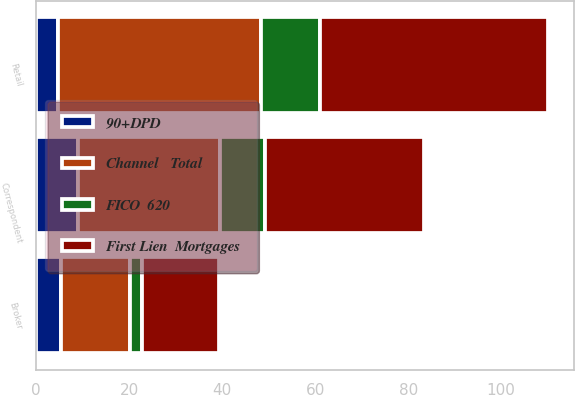Convert chart. <chart><loc_0><loc_0><loc_500><loc_500><stacked_bar_chart><ecel><fcel>Retail<fcel>Broker<fcel>Correspondent<nl><fcel>Channel   Total<fcel>43.6<fcel>14.8<fcel>30.6<nl><fcel>First Lien  Mortgages<fcel>49<fcel>16.7<fcel>34.3<nl><fcel>90+DPD<fcel>4.8<fcel>5.4<fcel>9<nl><fcel>FICO  620<fcel>12.7<fcel>2.5<fcel>9.6<nl></chart> 